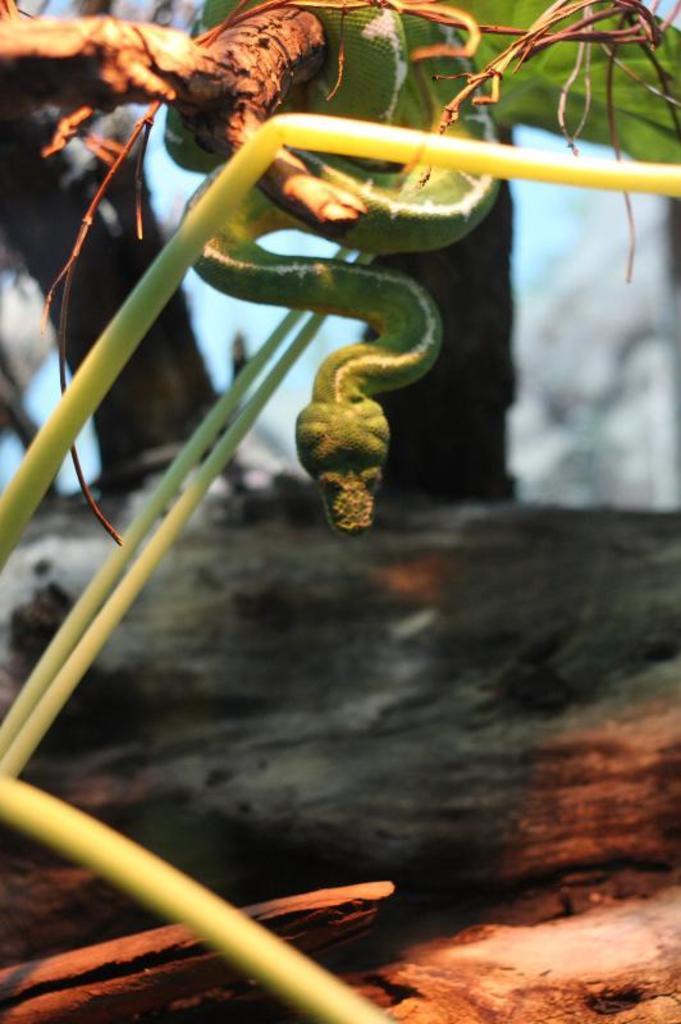In one or two sentences, can you explain what this image depicts? In this image in the foreground there are plants and at the top there is snake, and in the background also there are some trees. 